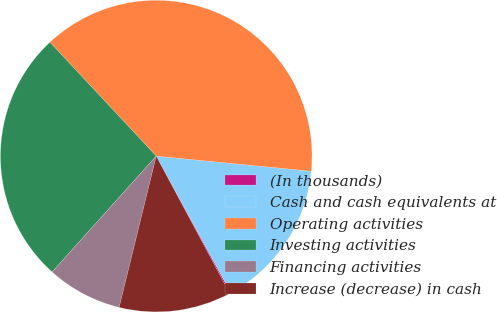<chart> <loc_0><loc_0><loc_500><loc_500><pie_chart><fcel>(In thousands)<fcel>Cash and cash equivalents at<fcel>Operating activities<fcel>Investing activities<fcel>Financing activities<fcel>Increase (decrease) in cash<nl><fcel>0.14%<fcel>15.49%<fcel>38.5%<fcel>26.4%<fcel>7.82%<fcel>11.65%<nl></chart> 